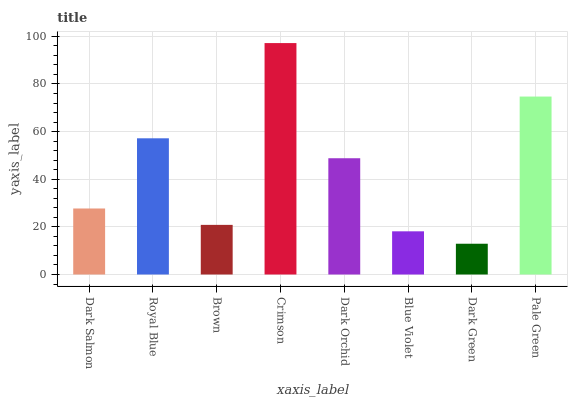Is Dark Green the minimum?
Answer yes or no. Yes. Is Crimson the maximum?
Answer yes or no. Yes. Is Royal Blue the minimum?
Answer yes or no. No. Is Royal Blue the maximum?
Answer yes or no. No. Is Royal Blue greater than Dark Salmon?
Answer yes or no. Yes. Is Dark Salmon less than Royal Blue?
Answer yes or no. Yes. Is Dark Salmon greater than Royal Blue?
Answer yes or no. No. Is Royal Blue less than Dark Salmon?
Answer yes or no. No. Is Dark Orchid the high median?
Answer yes or no. Yes. Is Dark Salmon the low median?
Answer yes or no. Yes. Is Dark Green the high median?
Answer yes or no. No. Is Crimson the low median?
Answer yes or no. No. 